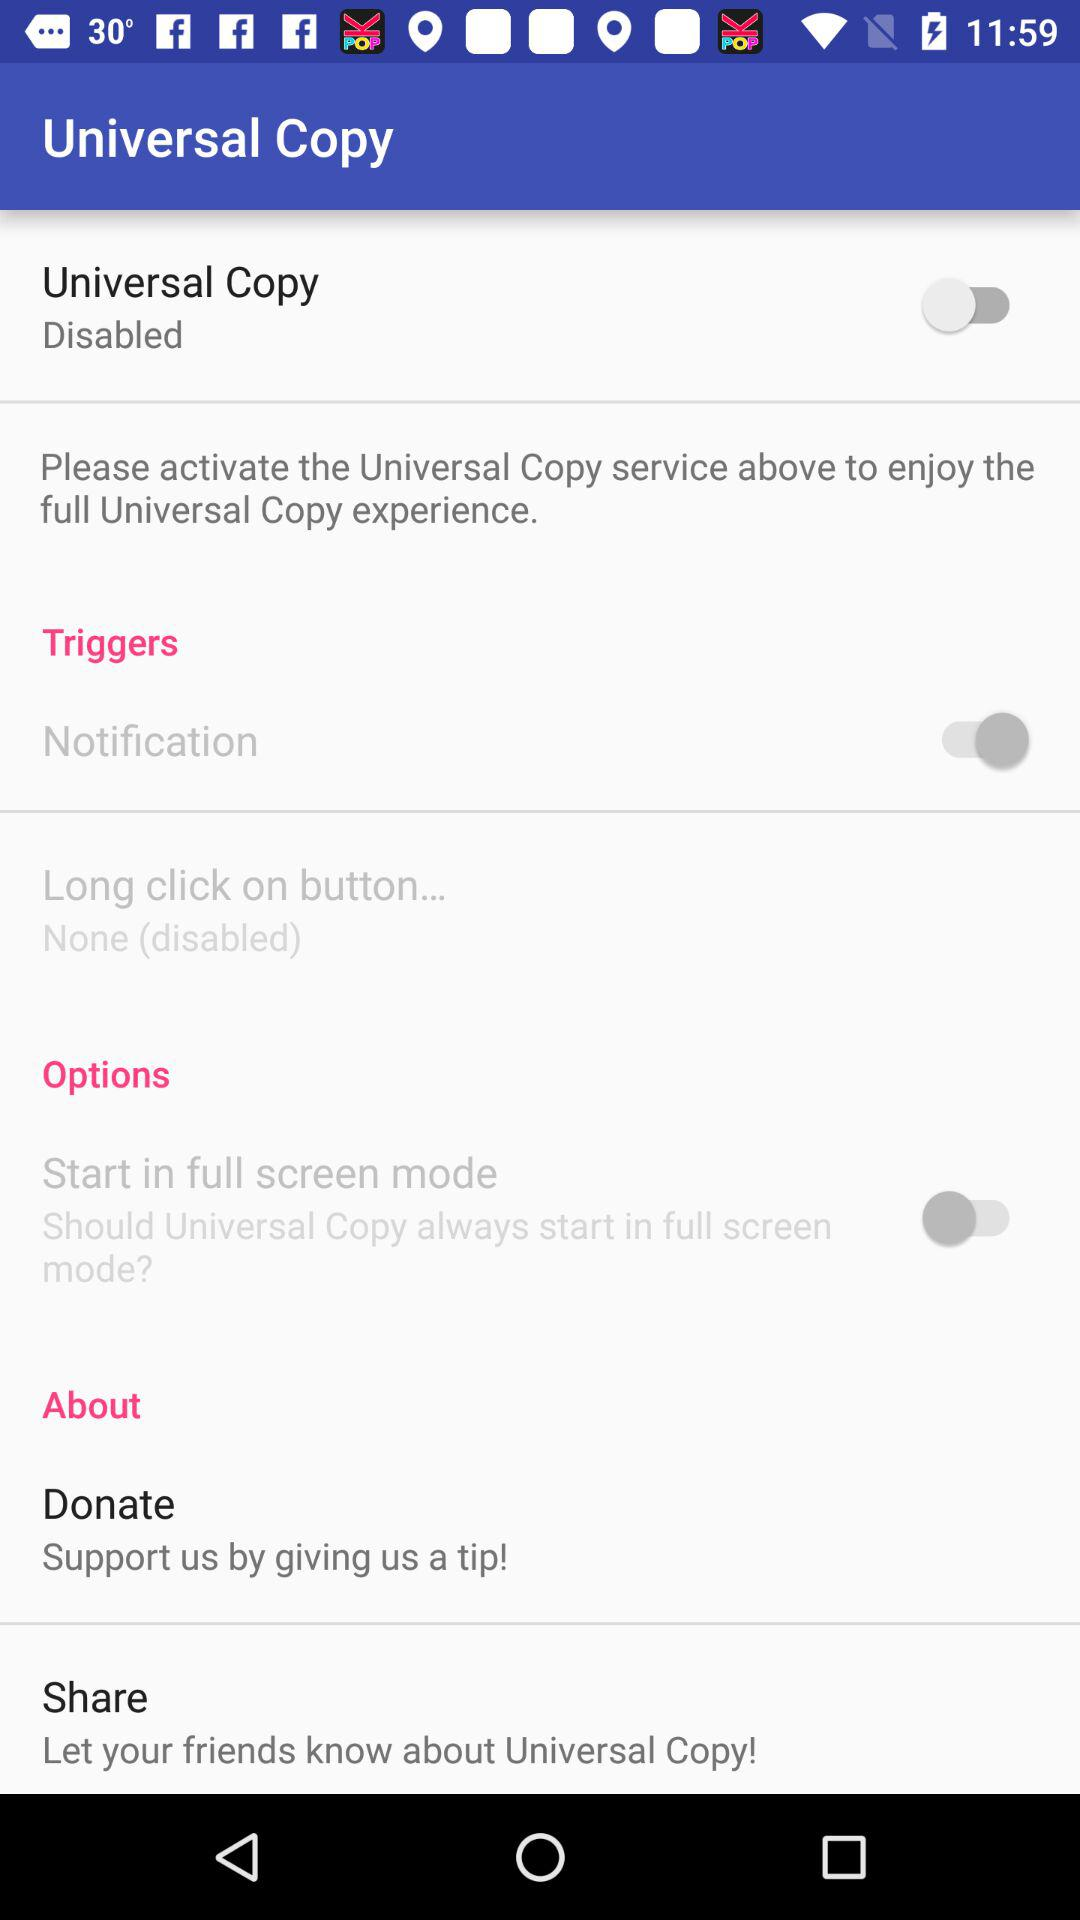What is the status of the "Notification"? The status of the "Notification" is "on". 